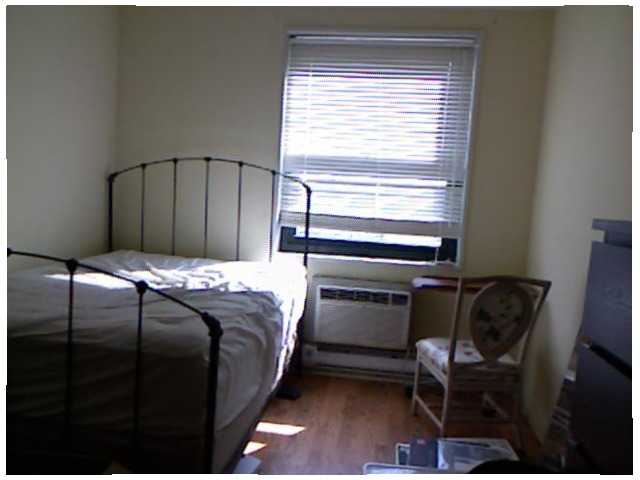<image>
Can you confirm if the bed is in front of the chair? No. The bed is not in front of the chair. The spatial positioning shows a different relationship between these objects. Where is the air conditioner in relation to the sunlight? Is it next to the sunlight? Yes. The air conditioner is positioned adjacent to the sunlight, located nearby in the same general area. Is there a air conditioner under the window? Yes. The air conditioner is positioned underneath the window, with the window above it in the vertical space. 